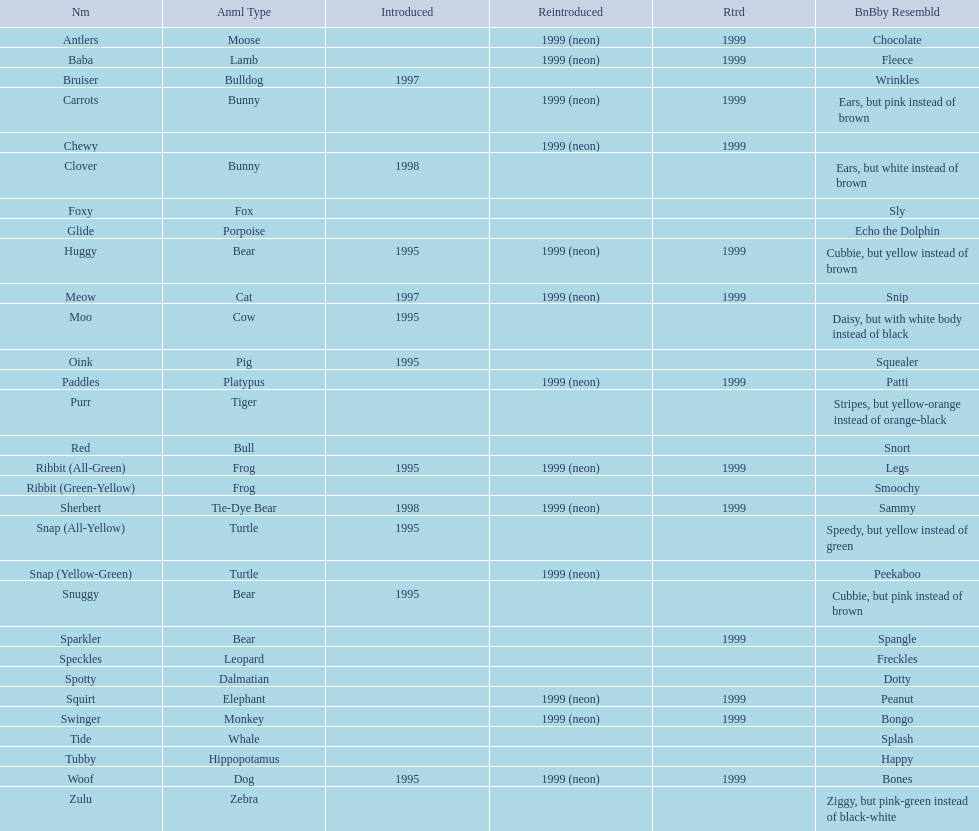Name the only pillow pal that is a dalmatian. Spotty. 